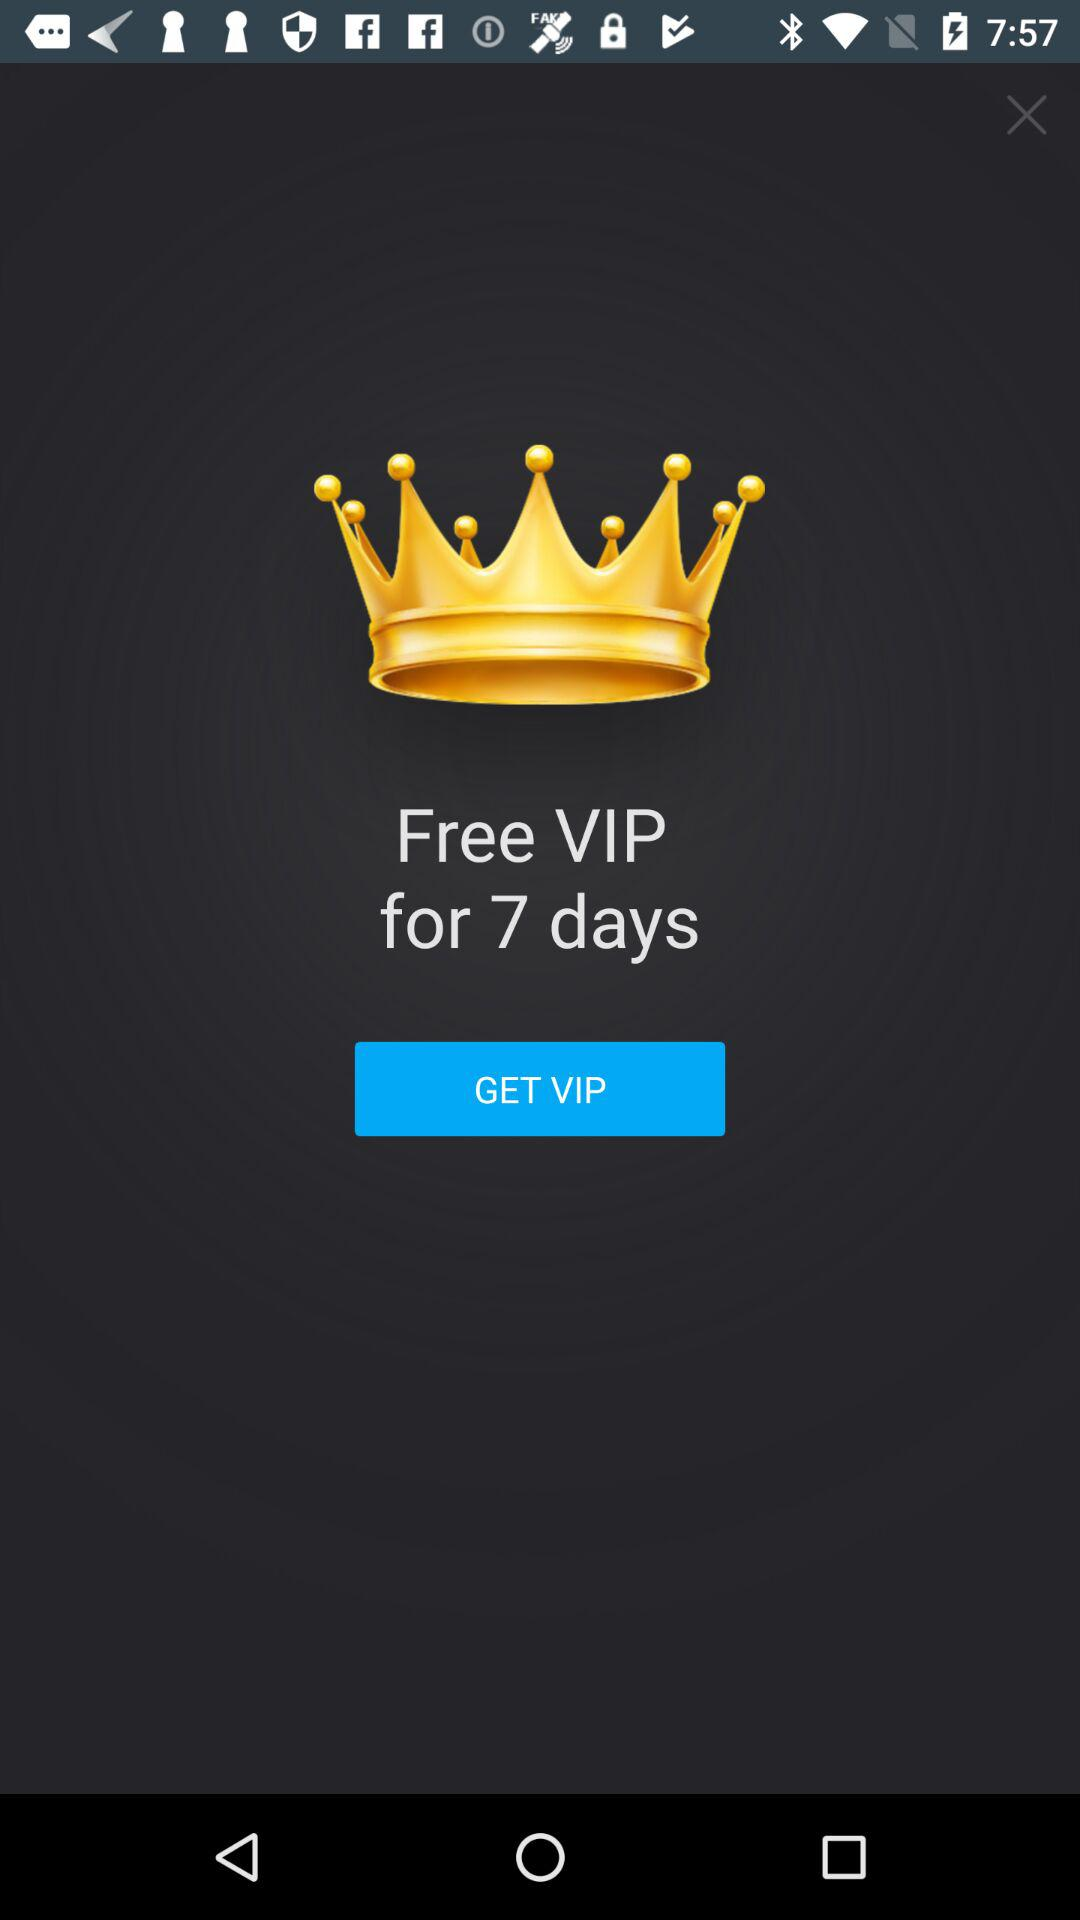What is the time limit for the free VIP membership? The time limit for the free VIP membership is 7 days. 